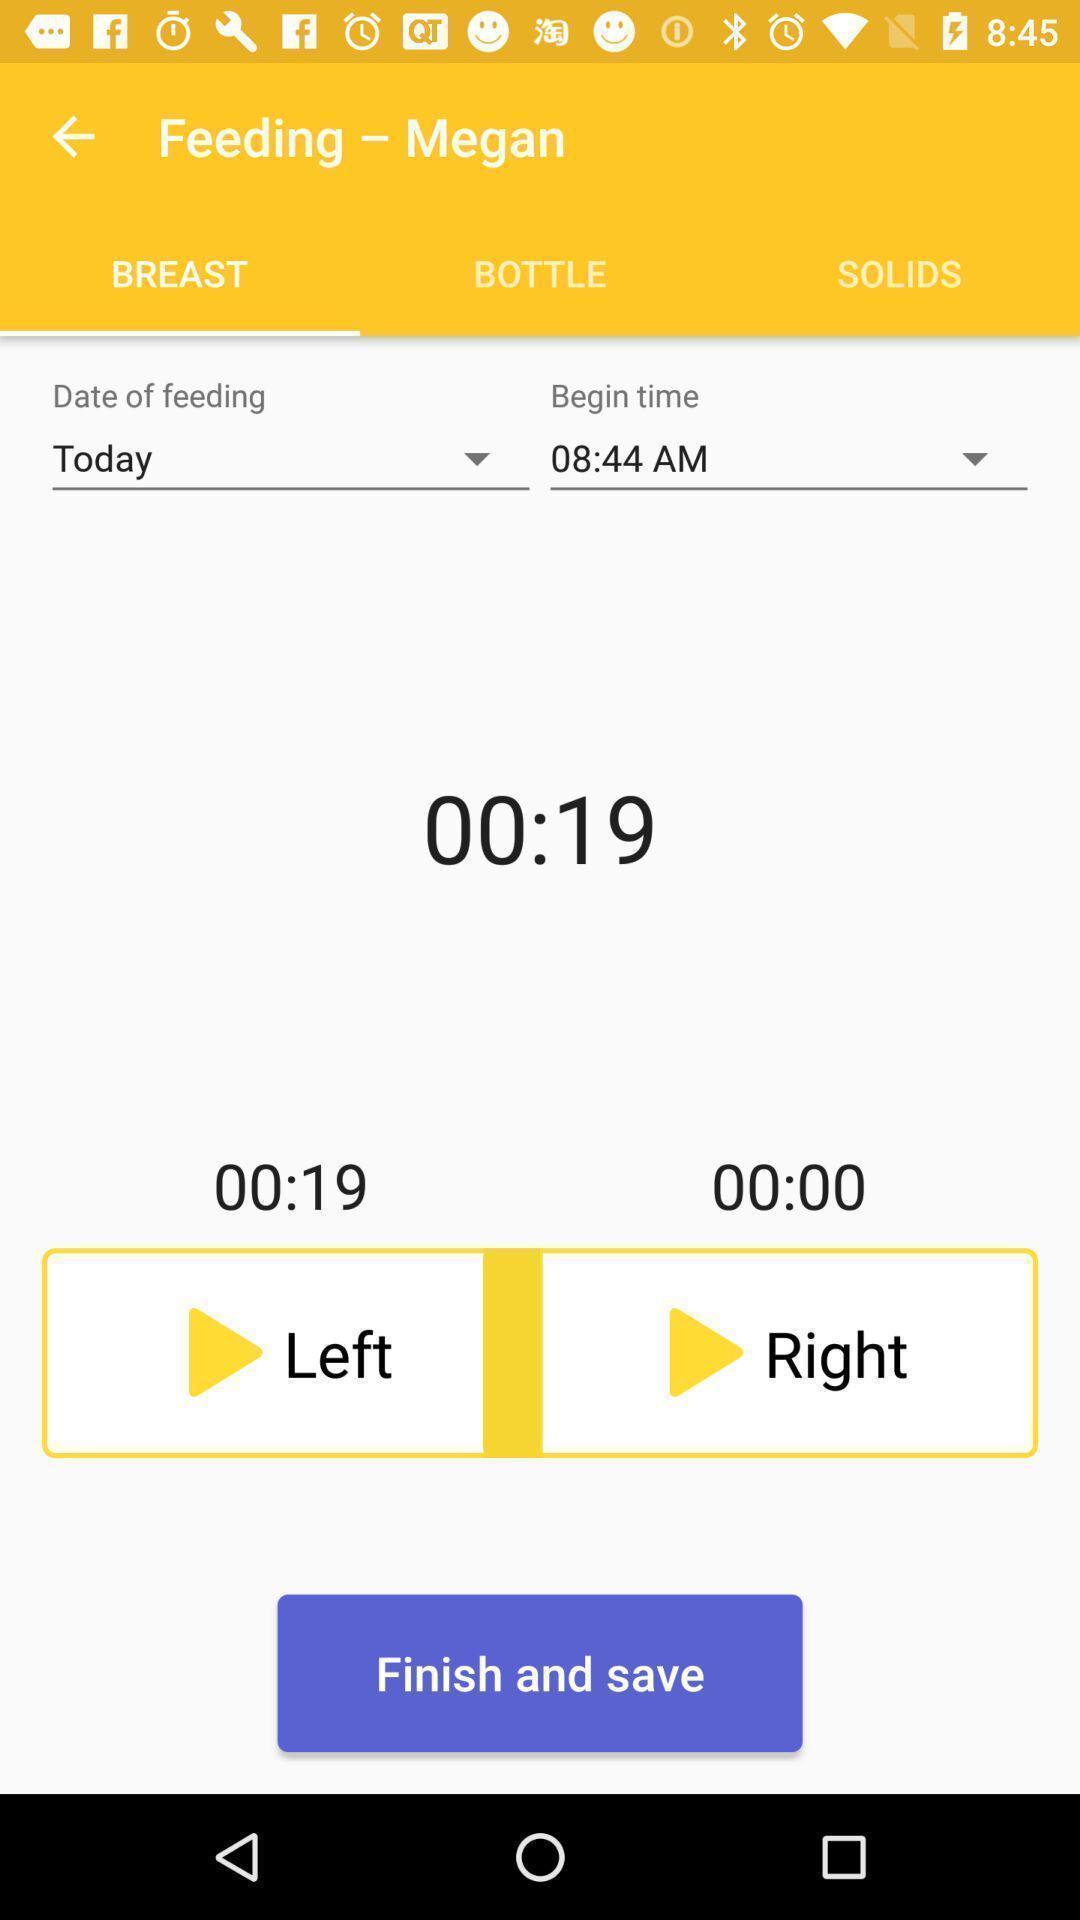Describe this image in words. Page of a baby manager app. 